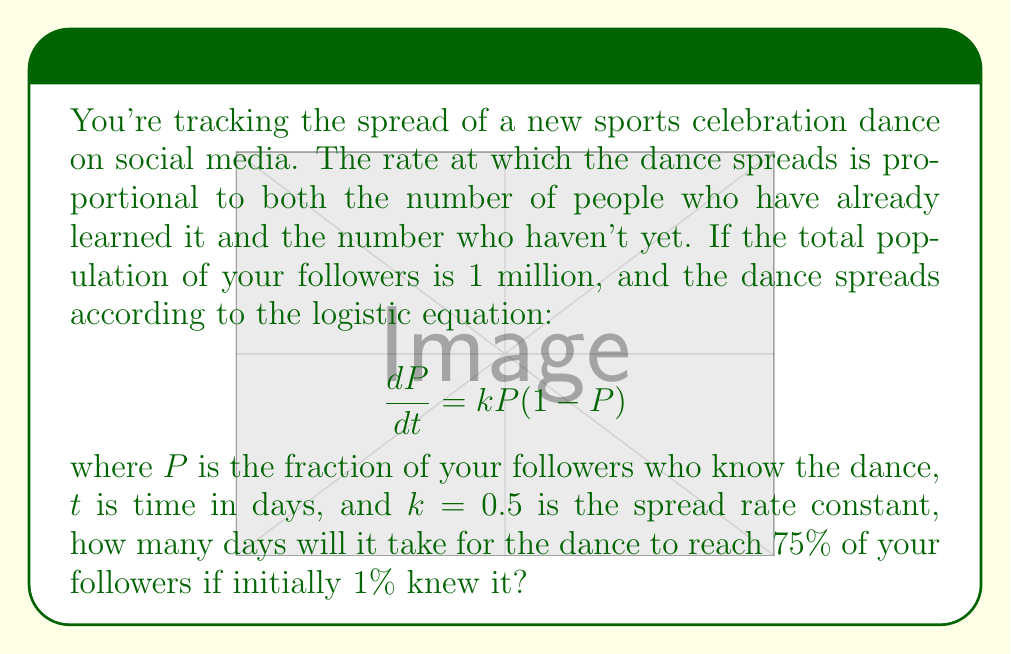Can you solve this math problem? Let's solve this step-by-step:

1) The logistic equation is given by:
   $$\frac{dP}{dt} = kP(1-P)$$

2) The solution to this differential equation is:
   $$P(t) = \frac{1}{1 + Ce^{-kt}}$$
   where $C$ is a constant determined by the initial conditions.

3) Initially, 1% of followers know the dance, so $P(0) = 0.01$. Let's find $C$:
   $$0.01 = \frac{1}{1 + C}$$
   $$C = 99$$

4) Now our equation is:
   $$P(t) = \frac{1}{1 + 99e^{-0.5t}}$$

5) We want to find $t$ when $P(t) = 0.75$:
   $$0.75 = \frac{1}{1 + 99e^{-0.5t}}$$

6) Solving for $t$:
   $$1 + 99e^{-0.5t} = \frac{4}{3}$$
   $$99e^{-0.5t} = \frac{1}{3}$$
   $$e^{-0.5t} = \frac{1}{297}$$
   $$-0.5t = \ln(\frac{1}{297})$$
   $$t = -2\ln(\frac{1}{297}) \approx 11.39$$

7) Therefore, it will take approximately 11.39 days for the dance to reach 75% of your followers.
Answer: 11.39 days 